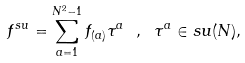<formula> <loc_0><loc_0><loc_500><loc_500>f ^ { s u } = \sum _ { a = 1 } ^ { N ^ { 2 } - 1 } f _ { ( a ) } \tau ^ { a } \ , \ \tau ^ { a } \in s u ( N ) ,</formula> 